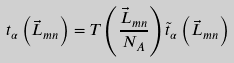Convert formula to latex. <formula><loc_0><loc_0><loc_500><loc_500>t _ { \alpha } \left ( { \vec { L } } _ { m n } \right ) = T \left ( \frac { { \vec { L } } _ { m n } } { N _ { A } } \right ) \tilde { t } _ { \alpha } \left ( { \vec { L } } _ { m n } \right )</formula> 